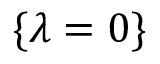<formula> <loc_0><loc_0><loc_500><loc_500>\{ \lambda = 0 \}</formula> 